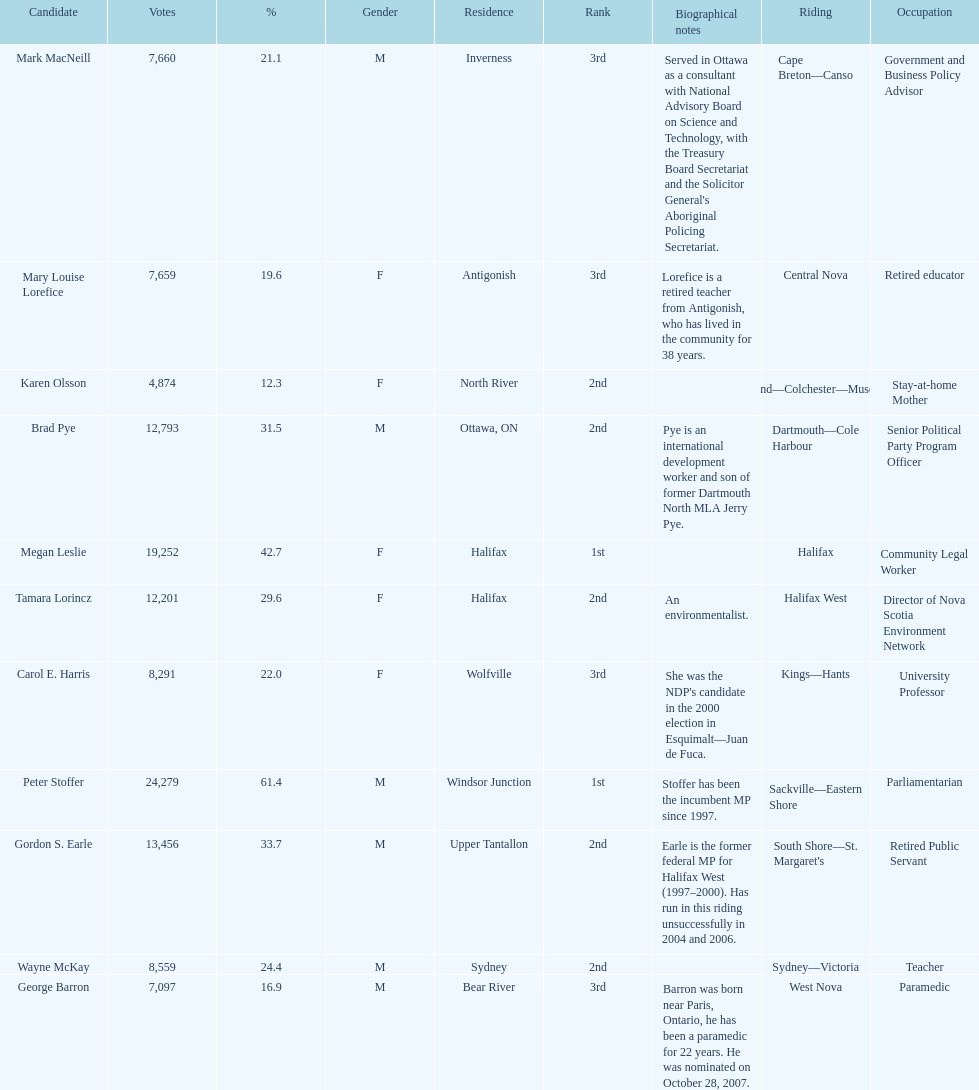How many of the candidates were females? 5. 